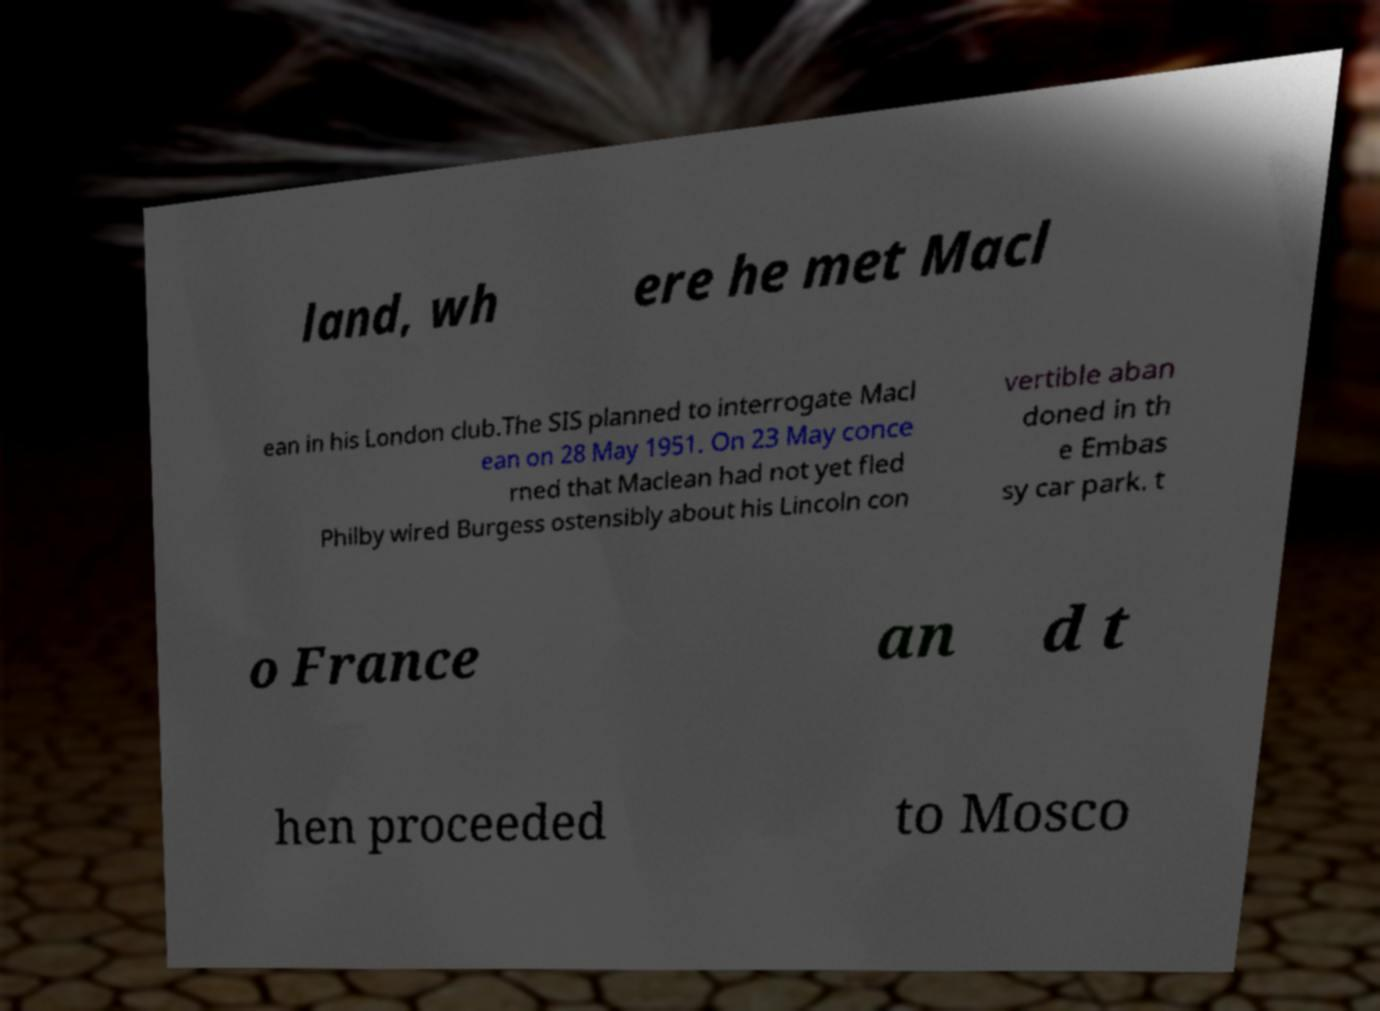Can you read and provide the text displayed in the image?This photo seems to have some interesting text. Can you extract and type it out for me? land, wh ere he met Macl ean in his London club.The SIS planned to interrogate Macl ean on 28 May 1951. On 23 May conce rned that Maclean had not yet fled Philby wired Burgess ostensibly about his Lincoln con vertible aban doned in th e Embas sy car park. t o France an d t hen proceeded to Mosco 